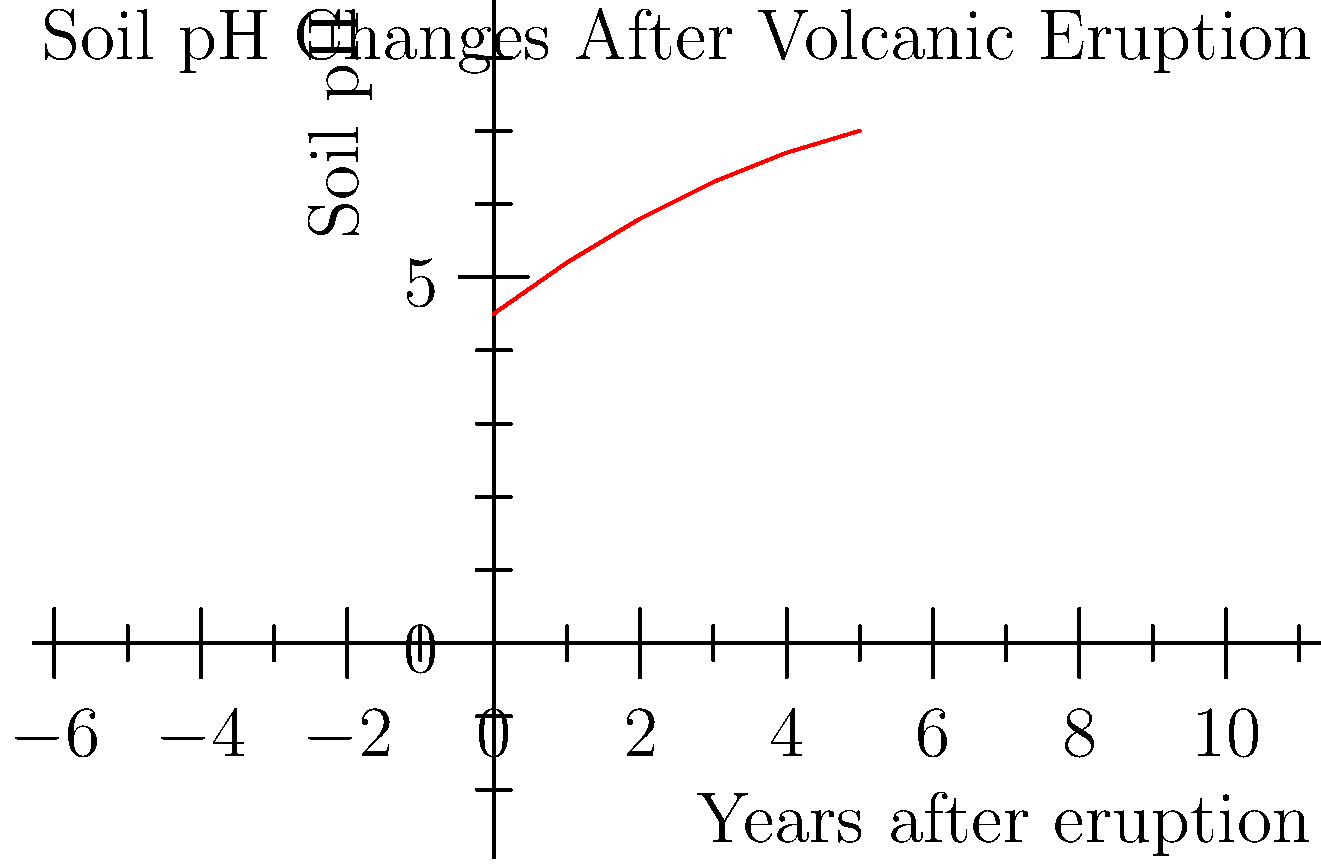Based on the line graph showing soil pH changes after a volcanic eruption, what is the approximate rate of pH increase per year during the first three years following the eruption? To calculate the rate of pH increase per year during the first three years:

1. Identify pH values:
   - Initial pH (Year 0): 4.5
   - pH at Year 3: 6.3

2. Calculate total pH change:
   $\Delta \text{pH} = 6.3 - 4.5 = 1.8$

3. Calculate rate of change:
   Rate = Total change / Time period
   $\text{Rate} = \frac{1.8 \text{ pH units}}{3 \text{ years}} = 0.6 \text{ pH units/year}$

Therefore, the approximate rate of pH increase per year during the first three years is 0.6 pH units/year.
Answer: 0.6 pH units/year 